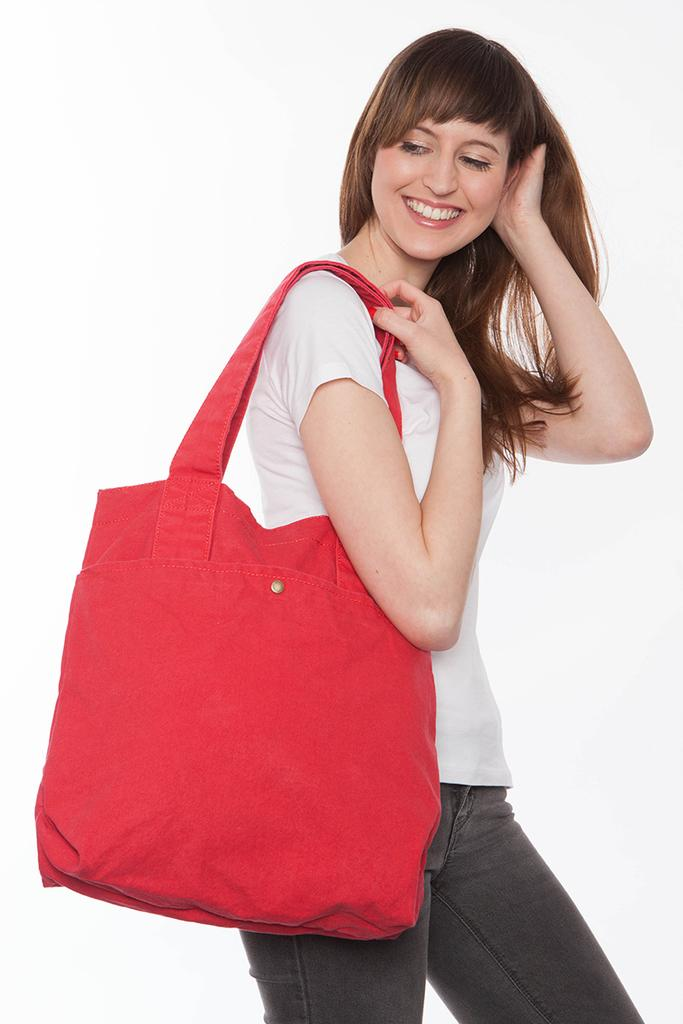What is present in the image? There is a person in the image. How is the person's facial expression? The person is smiling. What is the person holding in the image? The person is holding a bag. How many snakes are wrapped around the person's back in the image? There are no snakes present in the image. What type of leaf is visible on the person's shoulder in the image? There is no leaf visible on the person's shoulder in the image. 